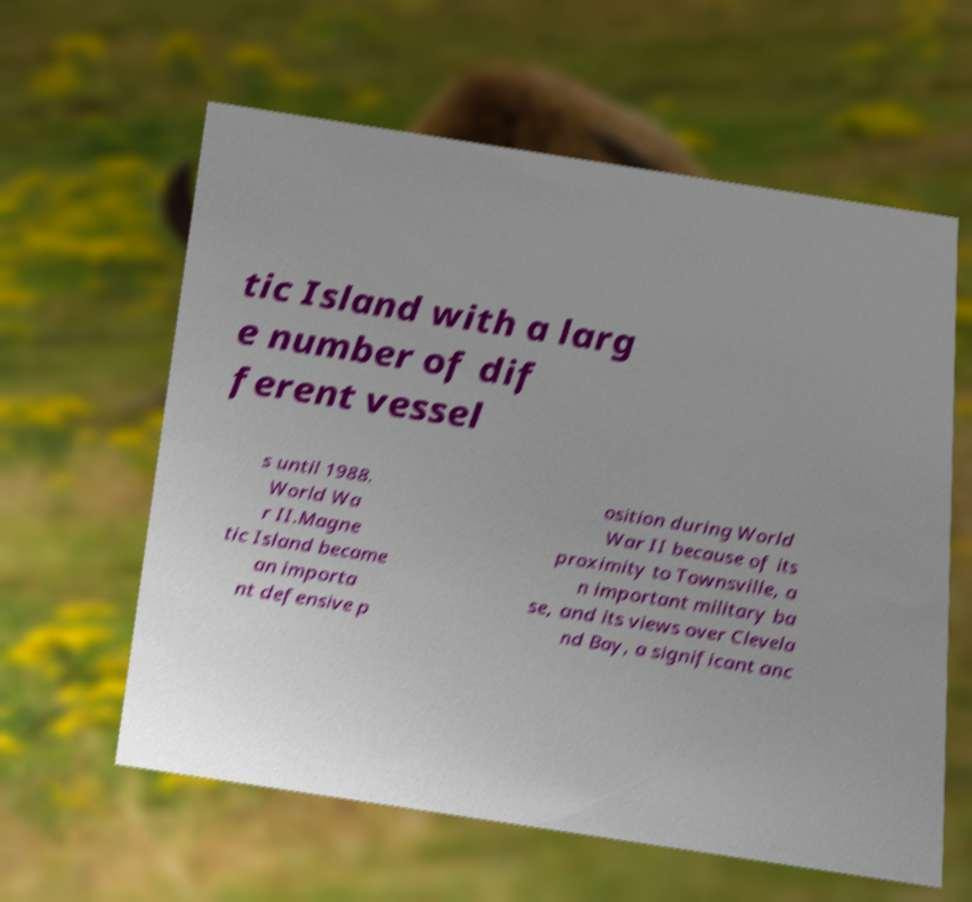I need the written content from this picture converted into text. Can you do that? tic Island with a larg e number of dif ferent vessel s until 1988. World Wa r II.Magne tic Island became an importa nt defensive p osition during World War II because of its proximity to Townsville, a n important military ba se, and its views over Clevela nd Bay, a significant anc 